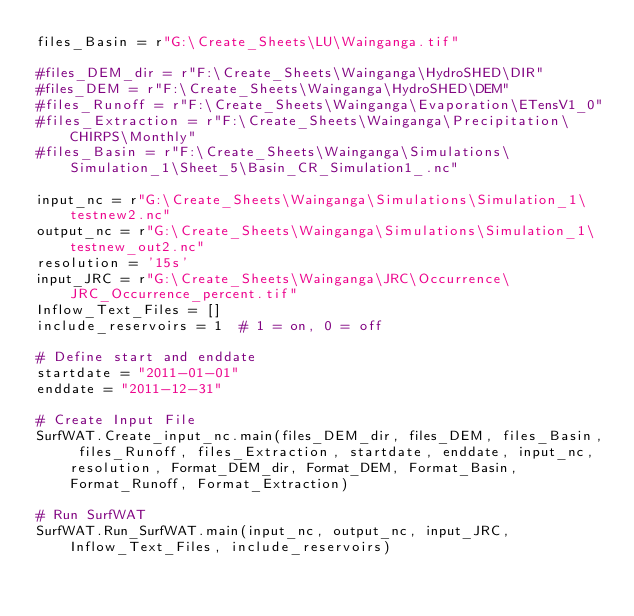<code> <loc_0><loc_0><loc_500><loc_500><_Python_>files_Basin = r"G:\Create_Sheets\LU\Wainganga.tif"

#files_DEM_dir = r"F:\Create_Sheets\Wainganga\HydroSHED\DIR"
#files_DEM = r"F:\Create_Sheets\Wainganga\HydroSHED\DEM"
#files_Runoff = r"F:\Create_Sheets\Wainganga\Evaporation\ETensV1_0"
#files_Extraction = r"F:\Create_Sheets\Wainganga\Precipitation\CHIRPS\Monthly"
#files_Basin = r"F:\Create_Sheets\Wainganga\Simulations\Simulation_1\Sheet_5\Basin_CR_Simulation1_.nc"

input_nc = r"G:\Create_Sheets\Wainganga\Simulations\Simulation_1\testnew2.nc"
output_nc = r"G:\Create_Sheets\Wainganga\Simulations\Simulation_1\testnew_out2.nc"
resolution = '15s'
input_JRC = r"G:\Create_Sheets\Wainganga\JRC\Occurrence\JRC_Occurrence_percent.tif"
Inflow_Text_Files = []
include_reservoirs = 1  # 1 = on, 0 = off

# Define start and enddate
startdate = "2011-01-01"
enddate = "2011-12-31"

# Create Input File
SurfWAT.Create_input_nc.main(files_DEM_dir, files_DEM, files_Basin, files_Runoff, files_Extraction, startdate, enddate, input_nc, resolution, Format_DEM_dir, Format_DEM, Format_Basin, Format_Runoff, Format_Extraction)

# Run SurfWAT
SurfWAT.Run_SurfWAT.main(input_nc, output_nc, input_JRC, Inflow_Text_Files, include_reservoirs)



</code> 